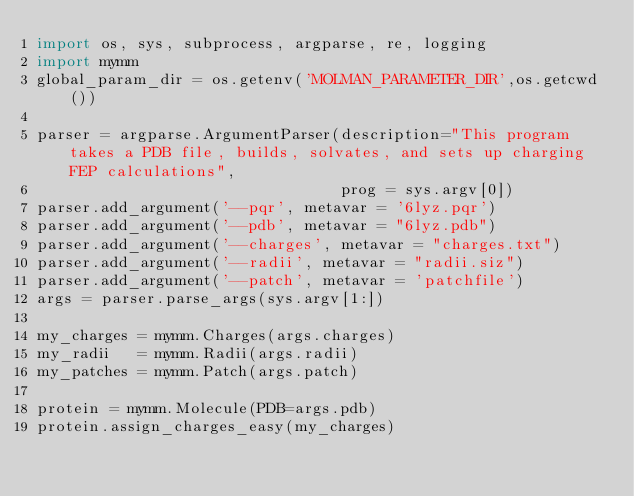Convert code to text. <code><loc_0><loc_0><loc_500><loc_500><_Python_>import os, sys, subprocess, argparse, re, logging
import mymm
global_param_dir = os.getenv('MOLMAN_PARAMETER_DIR',os.getcwd())
        
parser = argparse.ArgumentParser(description="This program takes a PDB file, builds, solvates, and sets up charging FEP calculations",
                                 prog = sys.argv[0])
parser.add_argument('--pqr', metavar = '6lyz.pqr')
parser.add_argument('--pdb', metavar = "6lyz.pdb")
parser.add_argument('--charges', metavar = "charges.txt")
parser.add_argument('--radii', metavar = "radii.siz")
parser.add_argument('--patch', metavar = 'patchfile')
args = parser.parse_args(sys.argv[1:])

my_charges = mymm.Charges(args.charges)
my_radii   = mymm.Radii(args.radii)
my_patches = mymm.Patch(args.patch)

protein = mymm.Molecule(PDB=args.pdb)
protein.assign_charges_easy(my_charges)
</code> 